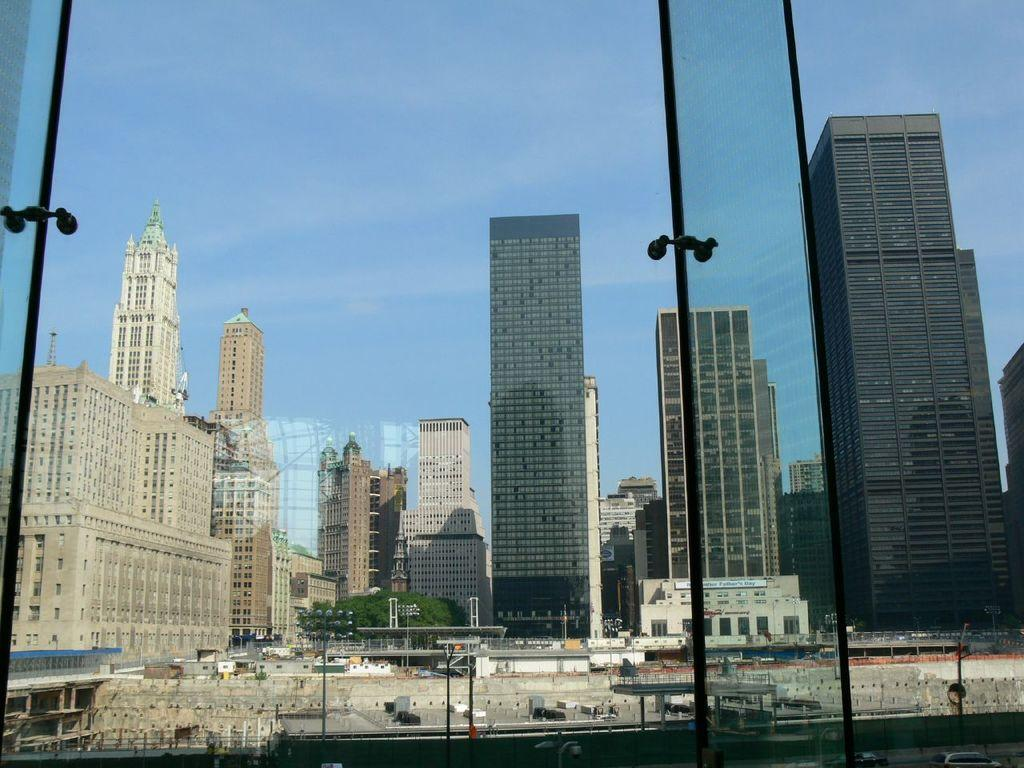What type of structures are present in the image? There are skyscrapers and buildings in the image. What is located at the bottom of the image? There is a road at the bottom of the image. What can be seen on the road? Vehicles are visible on the road. What natural element is present in the image? There is water in the image. What architectural feature is present in the image? A bridge is present in the image. What are the vertical structures in the image? Poles are visible in the image. What are the illumination sources in the image? Street lights are present in the image. What type of barrier is visible in the image? Fencing is visible in the image. What is visible at the top of the image? The sky is visible at the top of the image. What type of oatmeal is being served on the bridge in the image? There is no oatmeal present in the image, and the bridge is not serving any food. How many snakes are slithering on the skyscrapers in the image? There are no snakes present in the image; the skyscrapers are buildings, not habitats for snakes. 